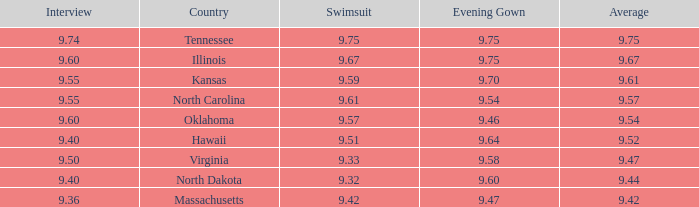Which country had the swimsuit score 9.67? Illinois. 